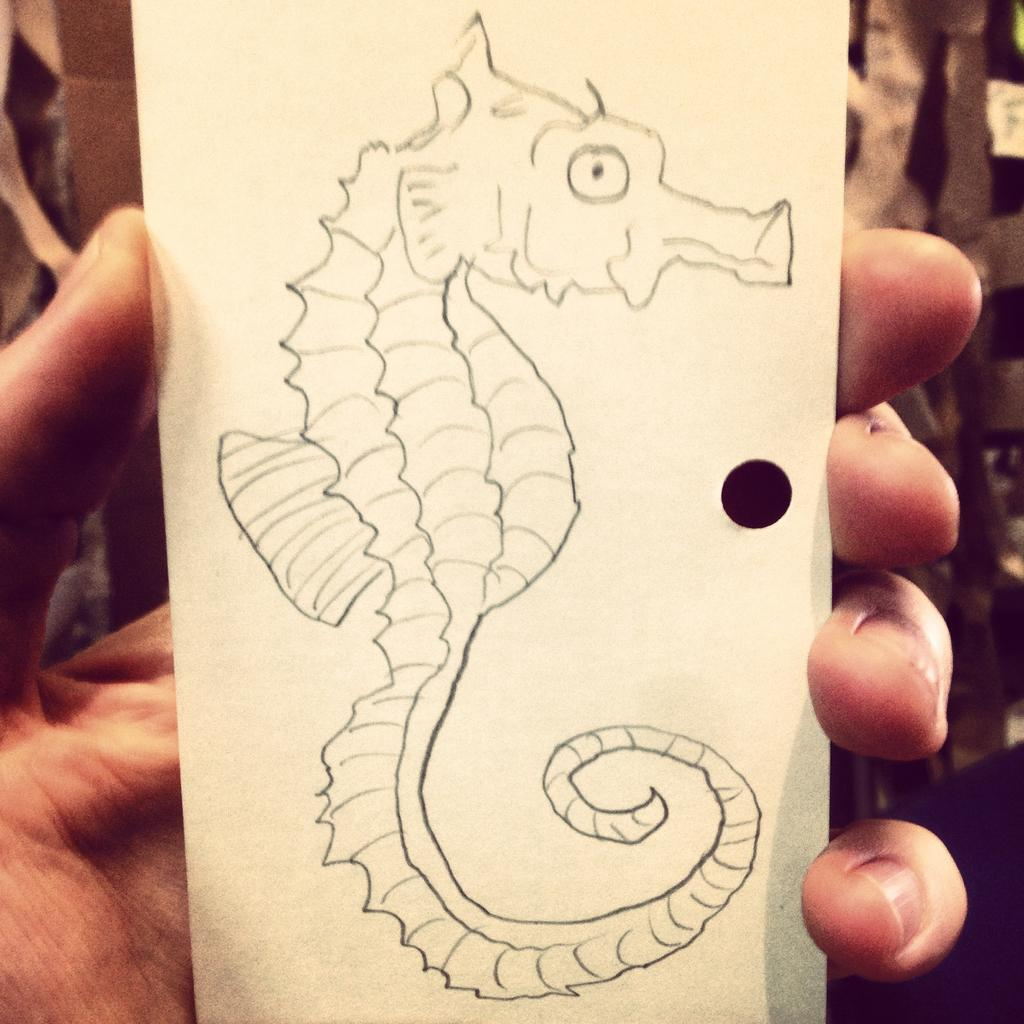What is the hand in the image holding? The hand is holding a small white color board. What is depicted on the board? An aquatic animal is drawn on the board. What type of background can be seen in the image? There is a wooden fence visible in the image. How does the hand measure the length of the aquatic animal on the board? The hand is not measuring the length of the aquatic animal on the board, as there is no indication of any measuring tool or action in the image. 